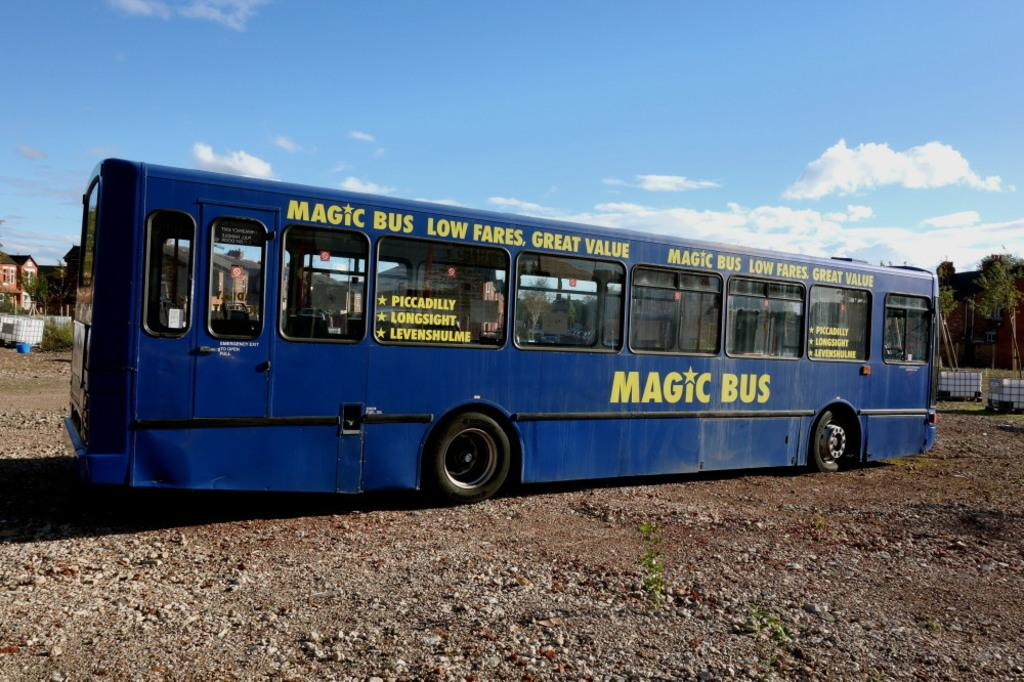What is the main subject of the picture? The main subject of the picture is a bus. What is the current state of the bus in the image? The bus is parked. Where is the bus parked in the image? The bus is parked in an empty place. What can be seen in the background of the picture? There are buildings and trees in the background of the picture. How is the sky depicted in the image? The sky is clear in the image. What type of bubble can be seen floating around the bus in the image? There is no bubble present in the image; it only features a parked bus in an empty place. Who is the writer of the book seen on the bus in the image? There is no book or writer mentioned in the image; it only shows a parked bus in an empty place. 